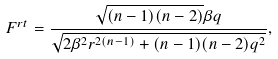Convert formula to latex. <formula><loc_0><loc_0><loc_500><loc_500>F ^ { r t } = \frac { \sqrt { ( n - 1 ) ( n - 2 ) } \beta q } { \sqrt { 2 \beta ^ { 2 } r ^ { 2 ( n - 1 ) } + ( n - 1 ) ( n - 2 ) q ^ { 2 } } } ,</formula> 